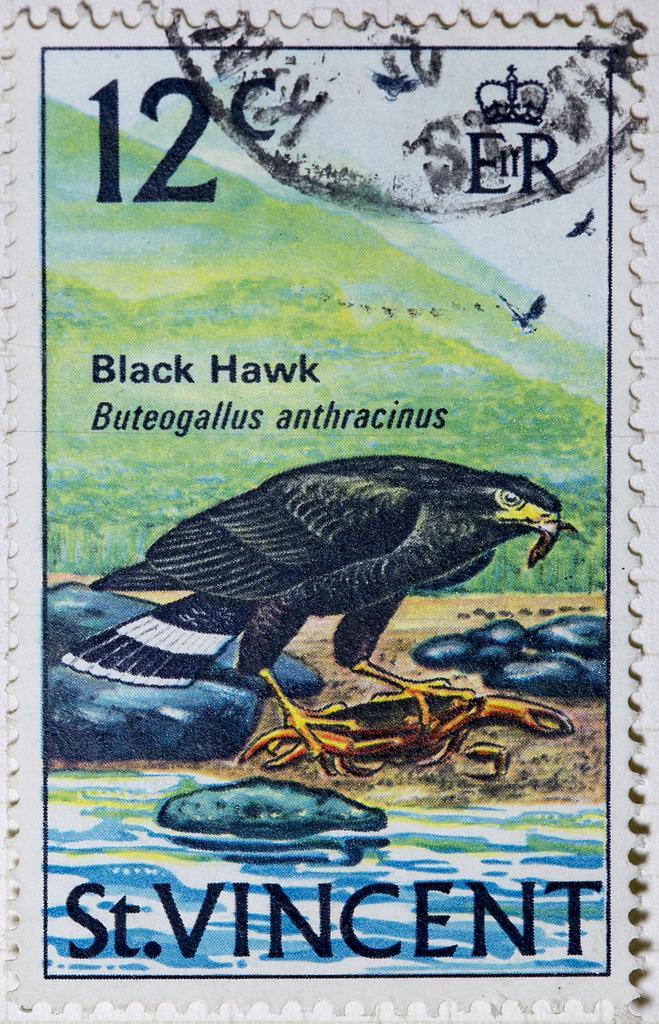Can you describe this image briefly? This image looks like a painting. There is a bird in the middle, which is in black color. There is water at the bottom. This looks like a stamp. 